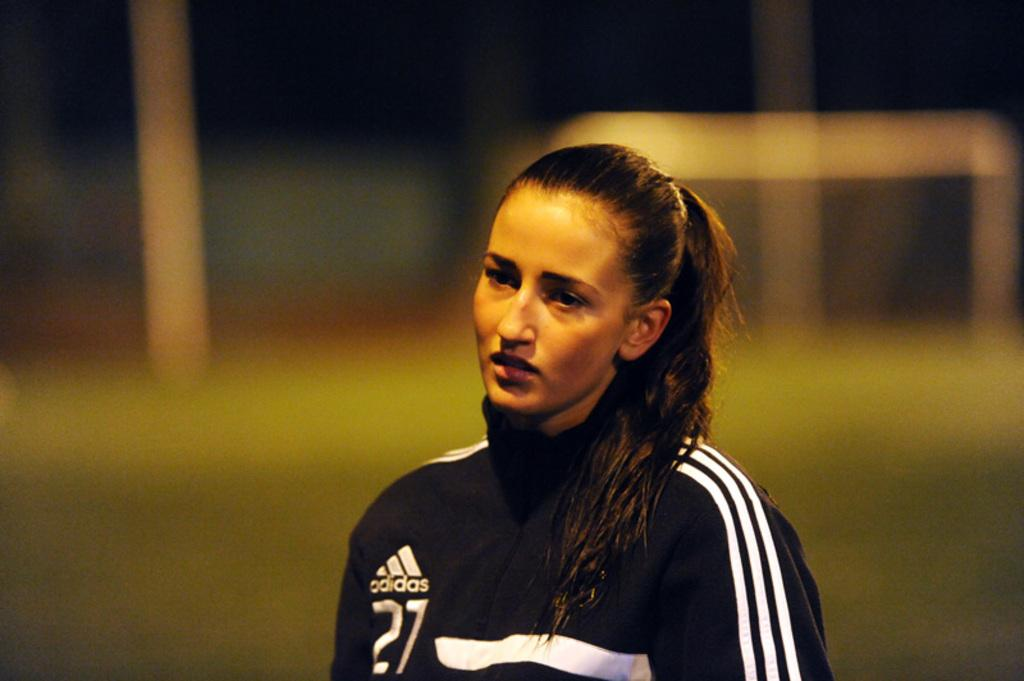<image>
Present a compact description of the photo's key features. A woman wears a blue jacket that was made by adidas. 